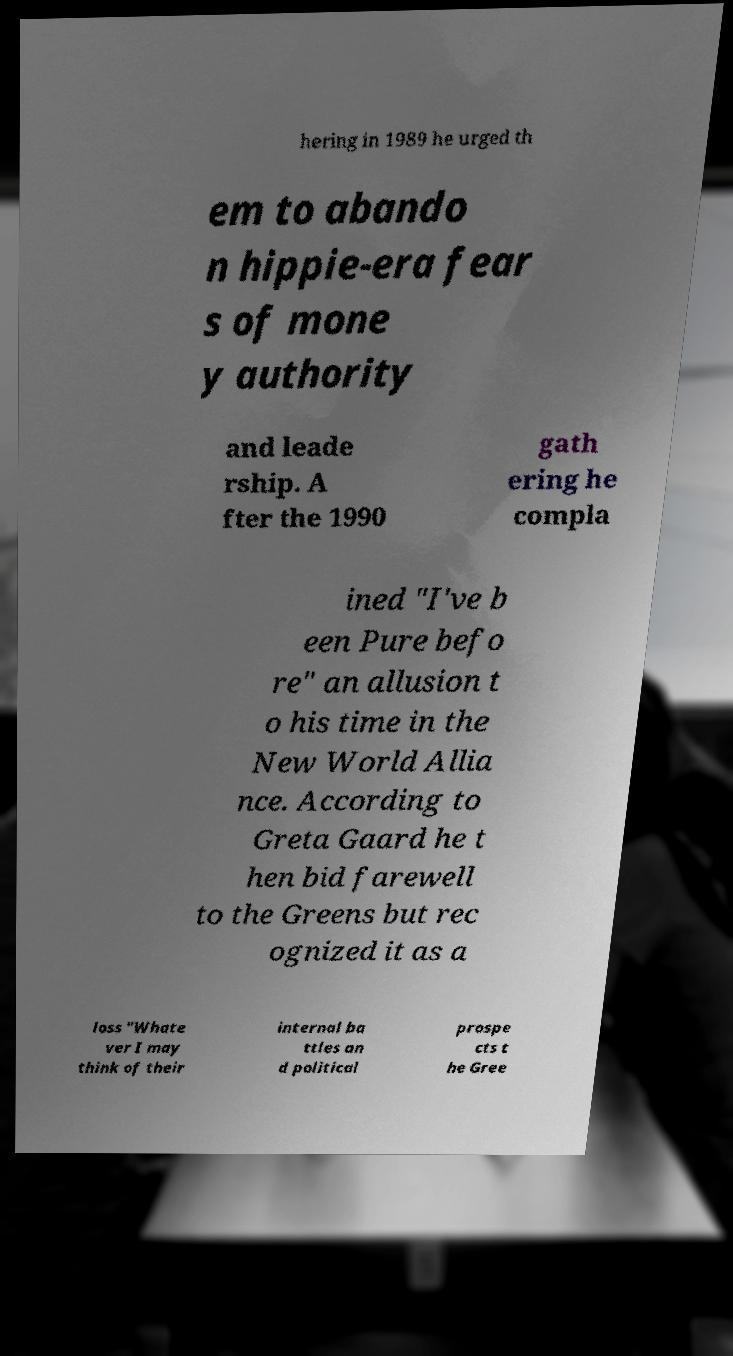What messages or text are displayed in this image? I need them in a readable, typed format. hering in 1989 he urged th em to abando n hippie-era fear s of mone y authority and leade rship. A fter the 1990 gath ering he compla ined "I've b een Pure befo re" an allusion t o his time in the New World Allia nce. According to Greta Gaard he t hen bid farewell to the Greens but rec ognized it as a loss "Whate ver I may think of their internal ba ttles an d political prospe cts t he Gree 